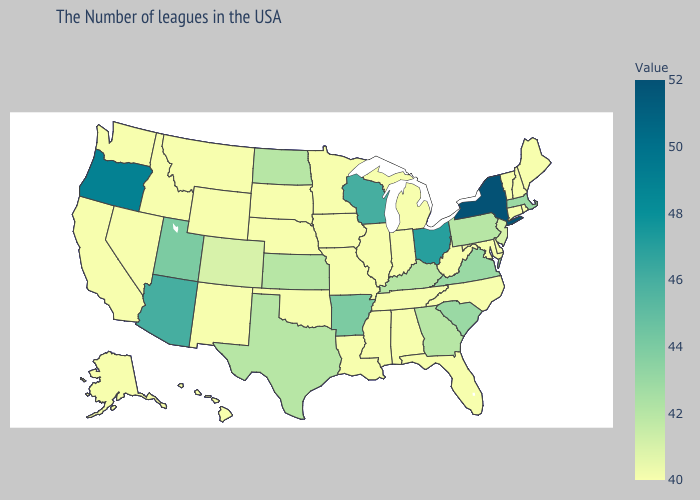Does Kansas have the lowest value in the USA?
Give a very brief answer. No. Is the legend a continuous bar?
Be succinct. Yes. Does Arkansas have the highest value in the South?
Give a very brief answer. Yes. Does the map have missing data?
Short answer required. No. 